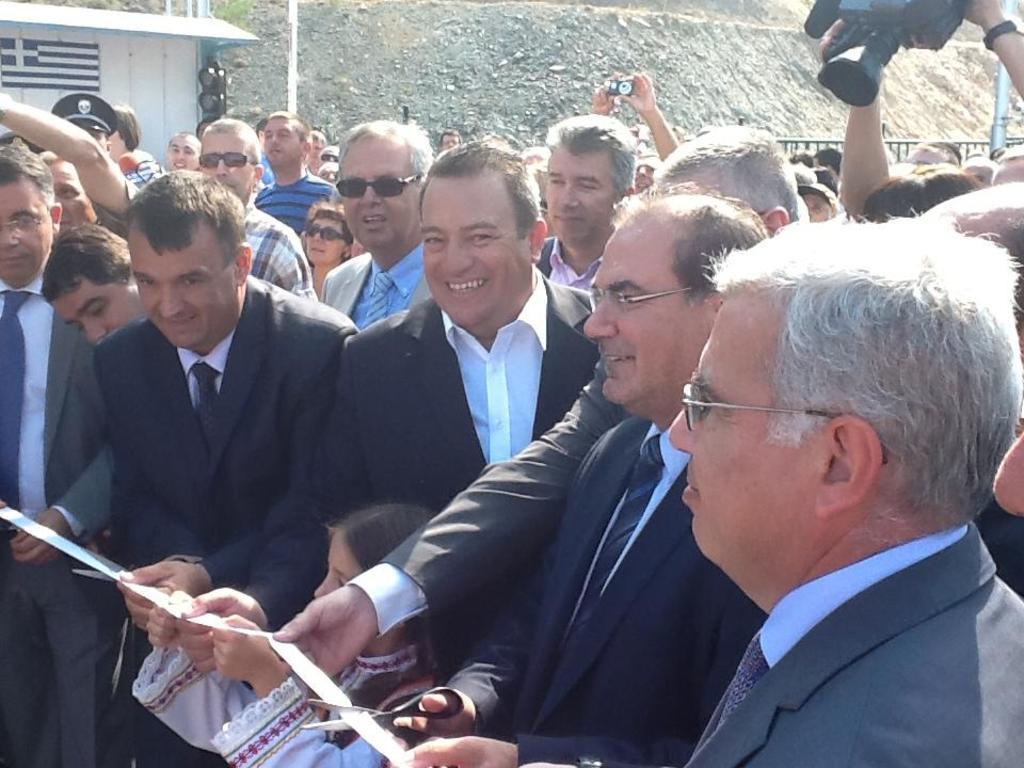Please provide a concise description of this image. In this image I can see number of people are standing. Here I can see the few of them are wearing formal dress, few of them are wearing shades, few of them are wearing specs and I can also see smile on few faces. here I can see few people are holding scissors and a white colour ribbon. I can also see a camera over here and in background I can see few lights. 